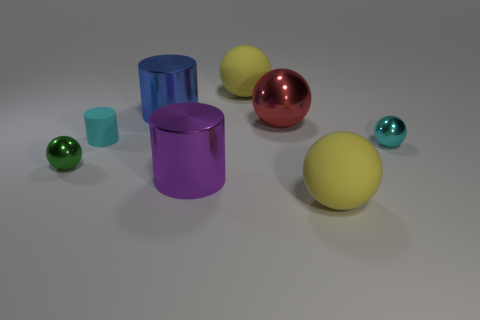Subtract all large red spheres. How many spheres are left? 4 Subtract all green balls. How many balls are left? 4 Subtract all brown spheres. Subtract all purple cubes. How many spheres are left? 5 Add 1 big matte cylinders. How many objects exist? 9 Subtract all cylinders. How many objects are left? 5 Add 4 red shiny things. How many red shiny things exist? 5 Subtract 0 brown cylinders. How many objects are left? 8 Subtract all large red metallic balls. Subtract all large cylinders. How many objects are left? 5 Add 7 big red metallic things. How many big red metallic things are left? 8 